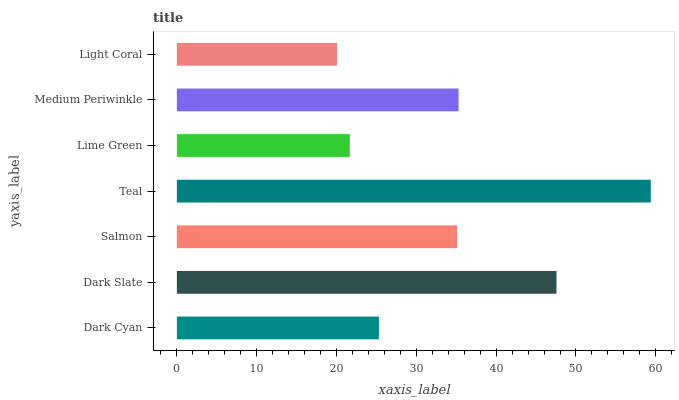Is Light Coral the minimum?
Answer yes or no. Yes. Is Teal the maximum?
Answer yes or no. Yes. Is Dark Slate the minimum?
Answer yes or no. No. Is Dark Slate the maximum?
Answer yes or no. No. Is Dark Slate greater than Dark Cyan?
Answer yes or no. Yes. Is Dark Cyan less than Dark Slate?
Answer yes or no. Yes. Is Dark Cyan greater than Dark Slate?
Answer yes or no. No. Is Dark Slate less than Dark Cyan?
Answer yes or no. No. Is Salmon the high median?
Answer yes or no. Yes. Is Salmon the low median?
Answer yes or no. Yes. Is Dark Cyan the high median?
Answer yes or no. No. Is Dark Slate the low median?
Answer yes or no. No. 